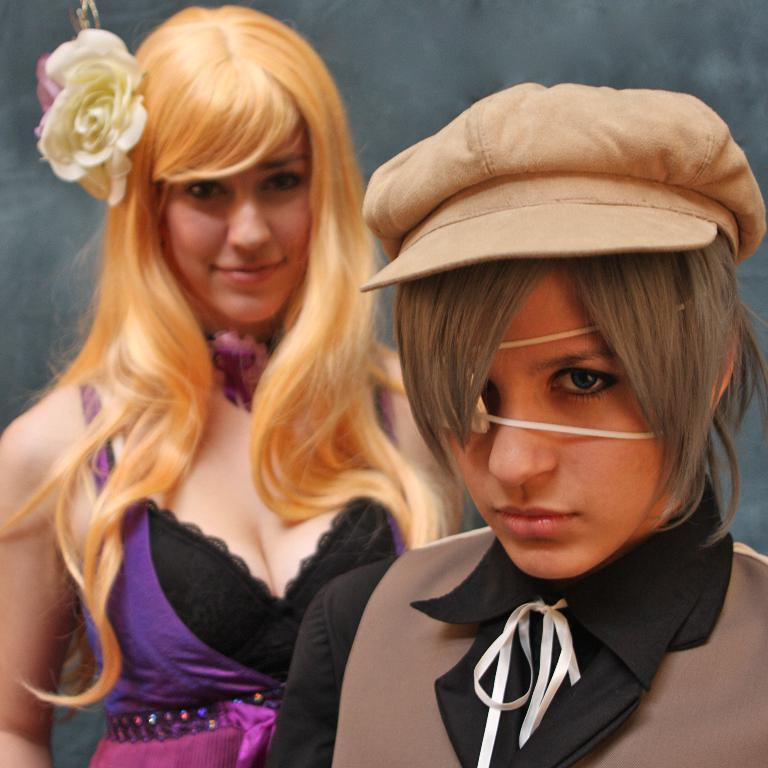How many girls are in the image? There are two girls in the image. Where is one of the girls located in the image? One girl is on the right side of the image. What is the girl on the right side wearing? The girl on the right side is wearing a cap. What objects can be seen in the image besides the girls? There is a ribbon and a flower in the image. What type of toy is the girl on the left side playing with in the image? There is no toy visible in the image, and the girl on the left side is not shown playing with anything. 